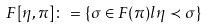<formula> <loc_0><loc_0><loc_500><loc_500>F [ \eta , \pi ] \colon = \{ \sigma \in F ( \pi ) l \eta \prec \sigma \}</formula> 